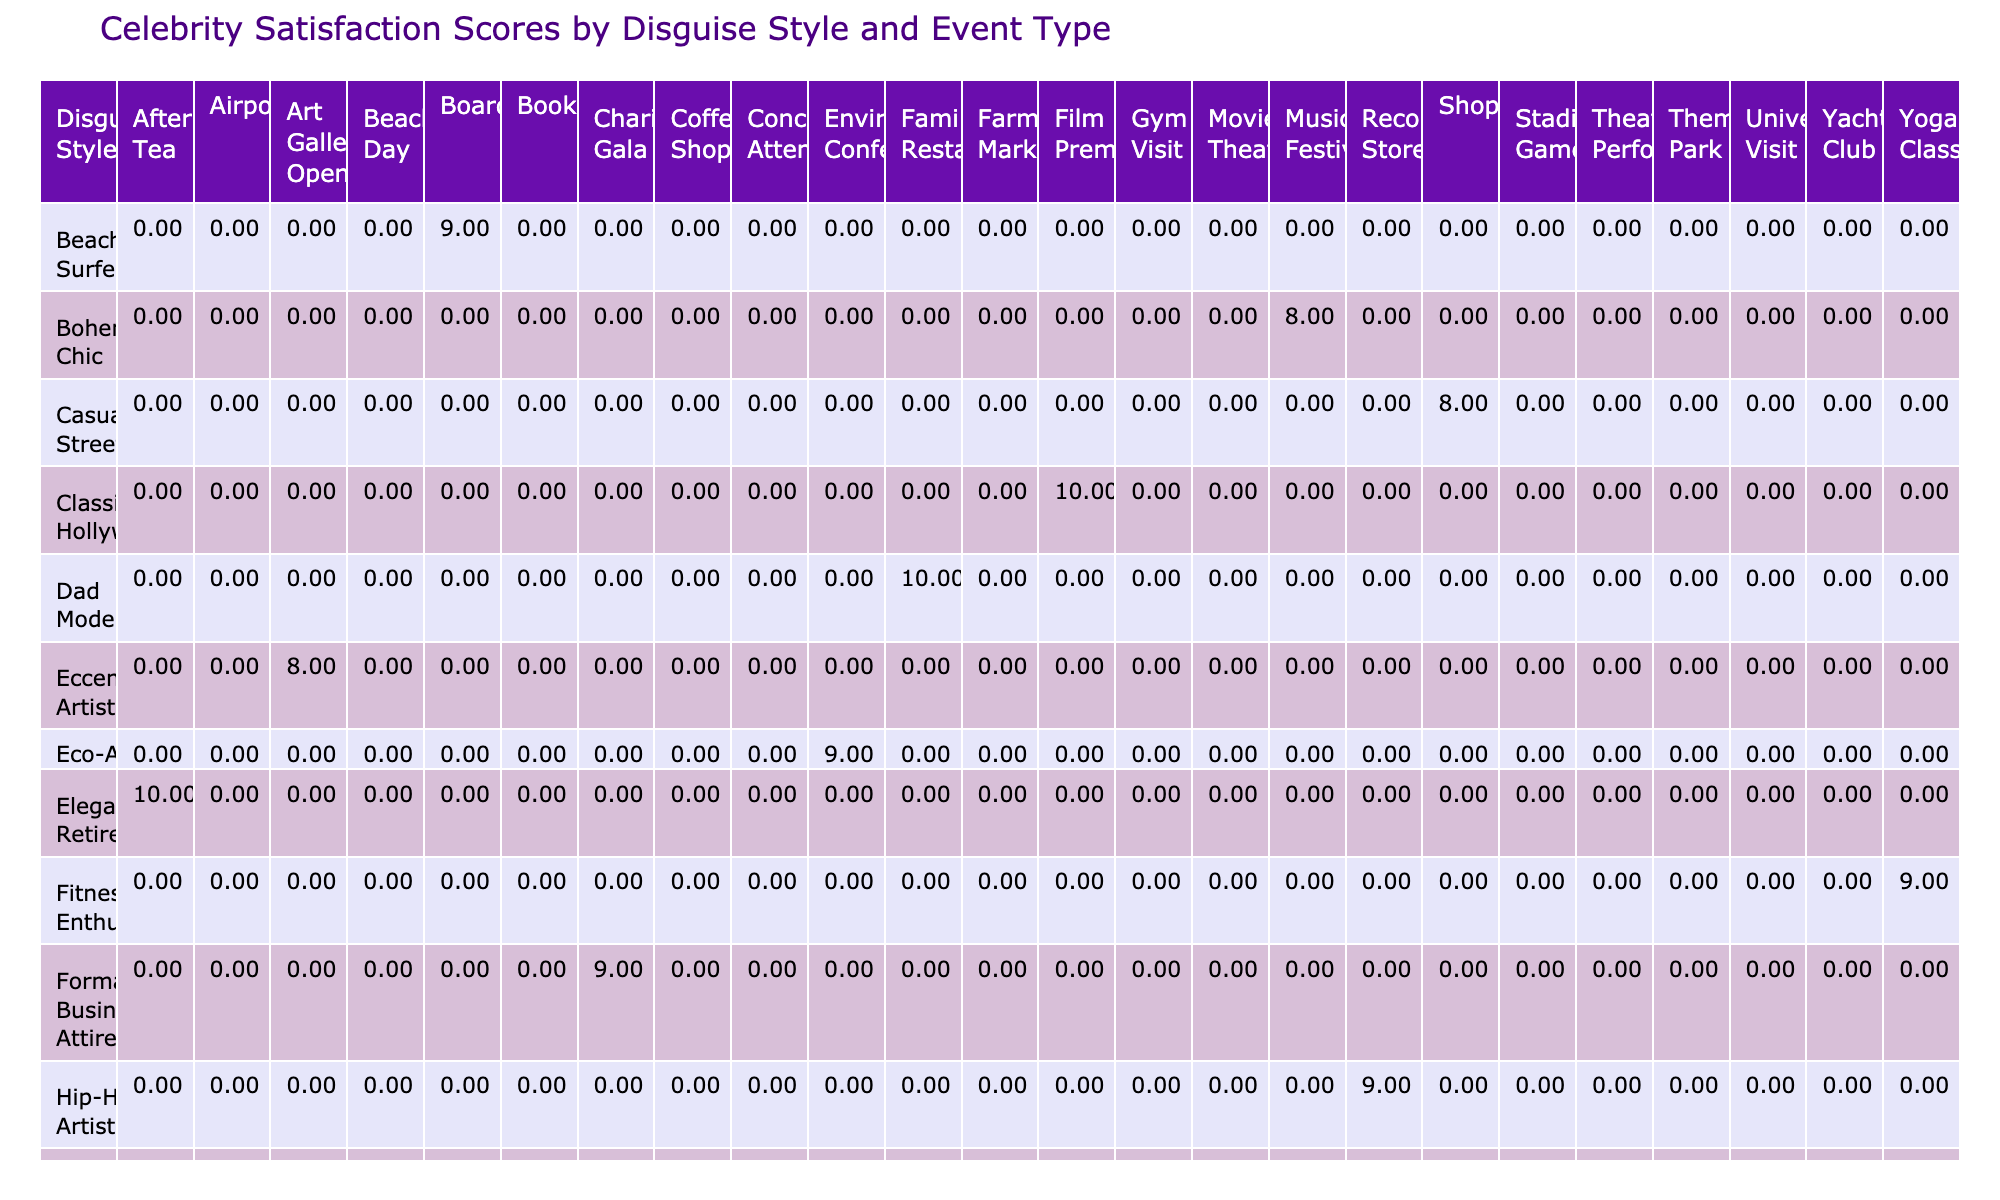What is the satisfaction score for Tom Cruise's disguise style? From the table, locate Tom Cruise under the "Disguise Style" row, where the corresponding "Event Type" is "Theme Park." The "Satisfaction Score" directly next to it reads 10.
Answer: 10 Which disguise style received the highest satisfaction score? By examining the "Satisfaction Score" column for each "Disguise Style," I can identify that "Vintage Glamour" and "Elegant Retiree" both achieve the highest score of 10.
Answer: Vintage Glamour, Elegant Retiree What is the average satisfaction score for all disguise styles used in gym events? The only disguise style for a gym event is "Sporty Athleisure," with a satisfaction score of 7. Since there's only one score, the average is also 7.
Answer: 7 Did any celebrity receive a satisfaction score of less than 8? By checking the table, I can identify names such as Beyoncé and Johnny Depp, whose scores of 7 confirm that indeed, they both received scores below 8.
Answer: Yes Which disguise style has the highest average satisfaction score across all event types? I need to sum the satisfaction scores for each disguise style and count the number of occurrences to calculate the average. For example, "Casual Streetwear" has 1 score of 8, "Formal Business Attire" has 1 score of 9, and so on. Upon calculations, "Vintage Glamour" and "Elegant Retiree" emerge as having the highest average, at 10.
Answer: Vintage Glamour, Elegant Retiree How many disguise styles scored 9 at charity gala events? Looking at the "Event Type" column, I find one entry under each disguise style: "Formal Business Attire" for Brad Pitt scored 9. There’s only one such style that received a score of 9 at this event.
Answer: 1 What percentage of all satisfaction scores are above 8? There are a total of 20 scores in the table. I count that 11 scores (10 from 1–2, and the others over 8) qualify as being above 8, which translates to (11/20) * 100 = 55%.
Answer: 55% Is there more than one style that scored a satisfaction score of 8? By reviewing the table, I can find several styles with a score of 8, including "Casual Streetwear," "Bohemian Chic," "Nerdy Student," "Eccentric Artist," and "Rugged Outdoorsman." Therefore, there is indeed more than one style that meets this criteria.
Answer: Yes Which event type has the average satisfaction score of 9? Summing and averaging satisfaction scores for each event type reveals that "Record Store" and "Yoga Class" specifically have scores averaging 9. I confirm this by evaluating the scores of associated disguise styles.
Answer: Record Store, Yoga Class 